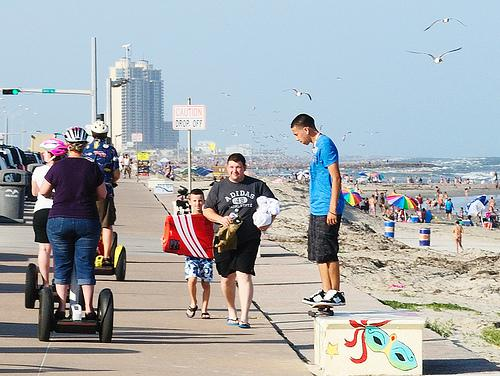Question: what is in the distance?
Choices:
A. A town.
B. A mountain.
C. A waterfall.
D. A building.
Answer with the letter. Answer: D Question: why are there shadows?
Choices:
A. The lights are on.
B. It is sunny.
C. There are candles burning.
D. It's afternoon.
Answer with the letter. Answer: B Question: how many people are on scooters?
Choices:
A. 3.
B. 4.
C. 5.
D. 6.
Answer with the letter. Answer: A Question: who has a helmet?
Choices:
A. The people on horses.
B. The skateboarders.
C. The hockey players.
D. The people on scooters.
Answer with the letter. Answer: D Question: what do people have on the beach?
Choices:
A. Umbrellas.
B. Towels.
C. Buckets.
D. Dogs.
Answer with the letter. Answer: A 